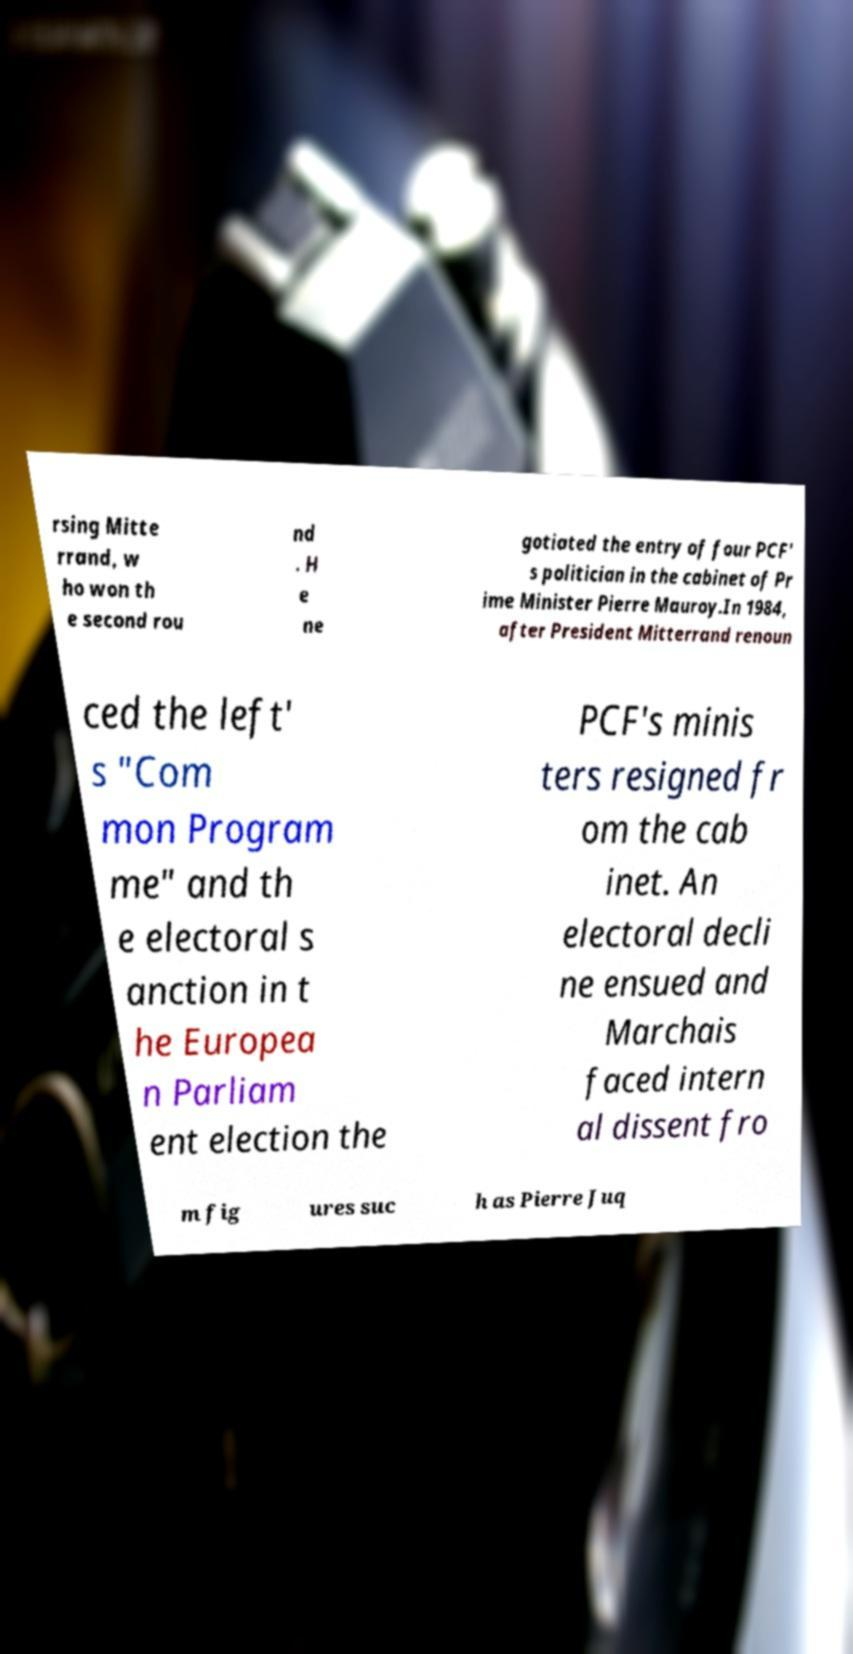Please read and relay the text visible in this image. What does it say? rsing Mitte rrand, w ho won th e second rou nd . H e ne gotiated the entry of four PCF' s politician in the cabinet of Pr ime Minister Pierre Mauroy.In 1984, after President Mitterrand renoun ced the left' s "Com mon Program me" and th e electoral s anction in t he Europea n Parliam ent election the PCF's minis ters resigned fr om the cab inet. An electoral decli ne ensued and Marchais faced intern al dissent fro m fig ures suc h as Pierre Juq 